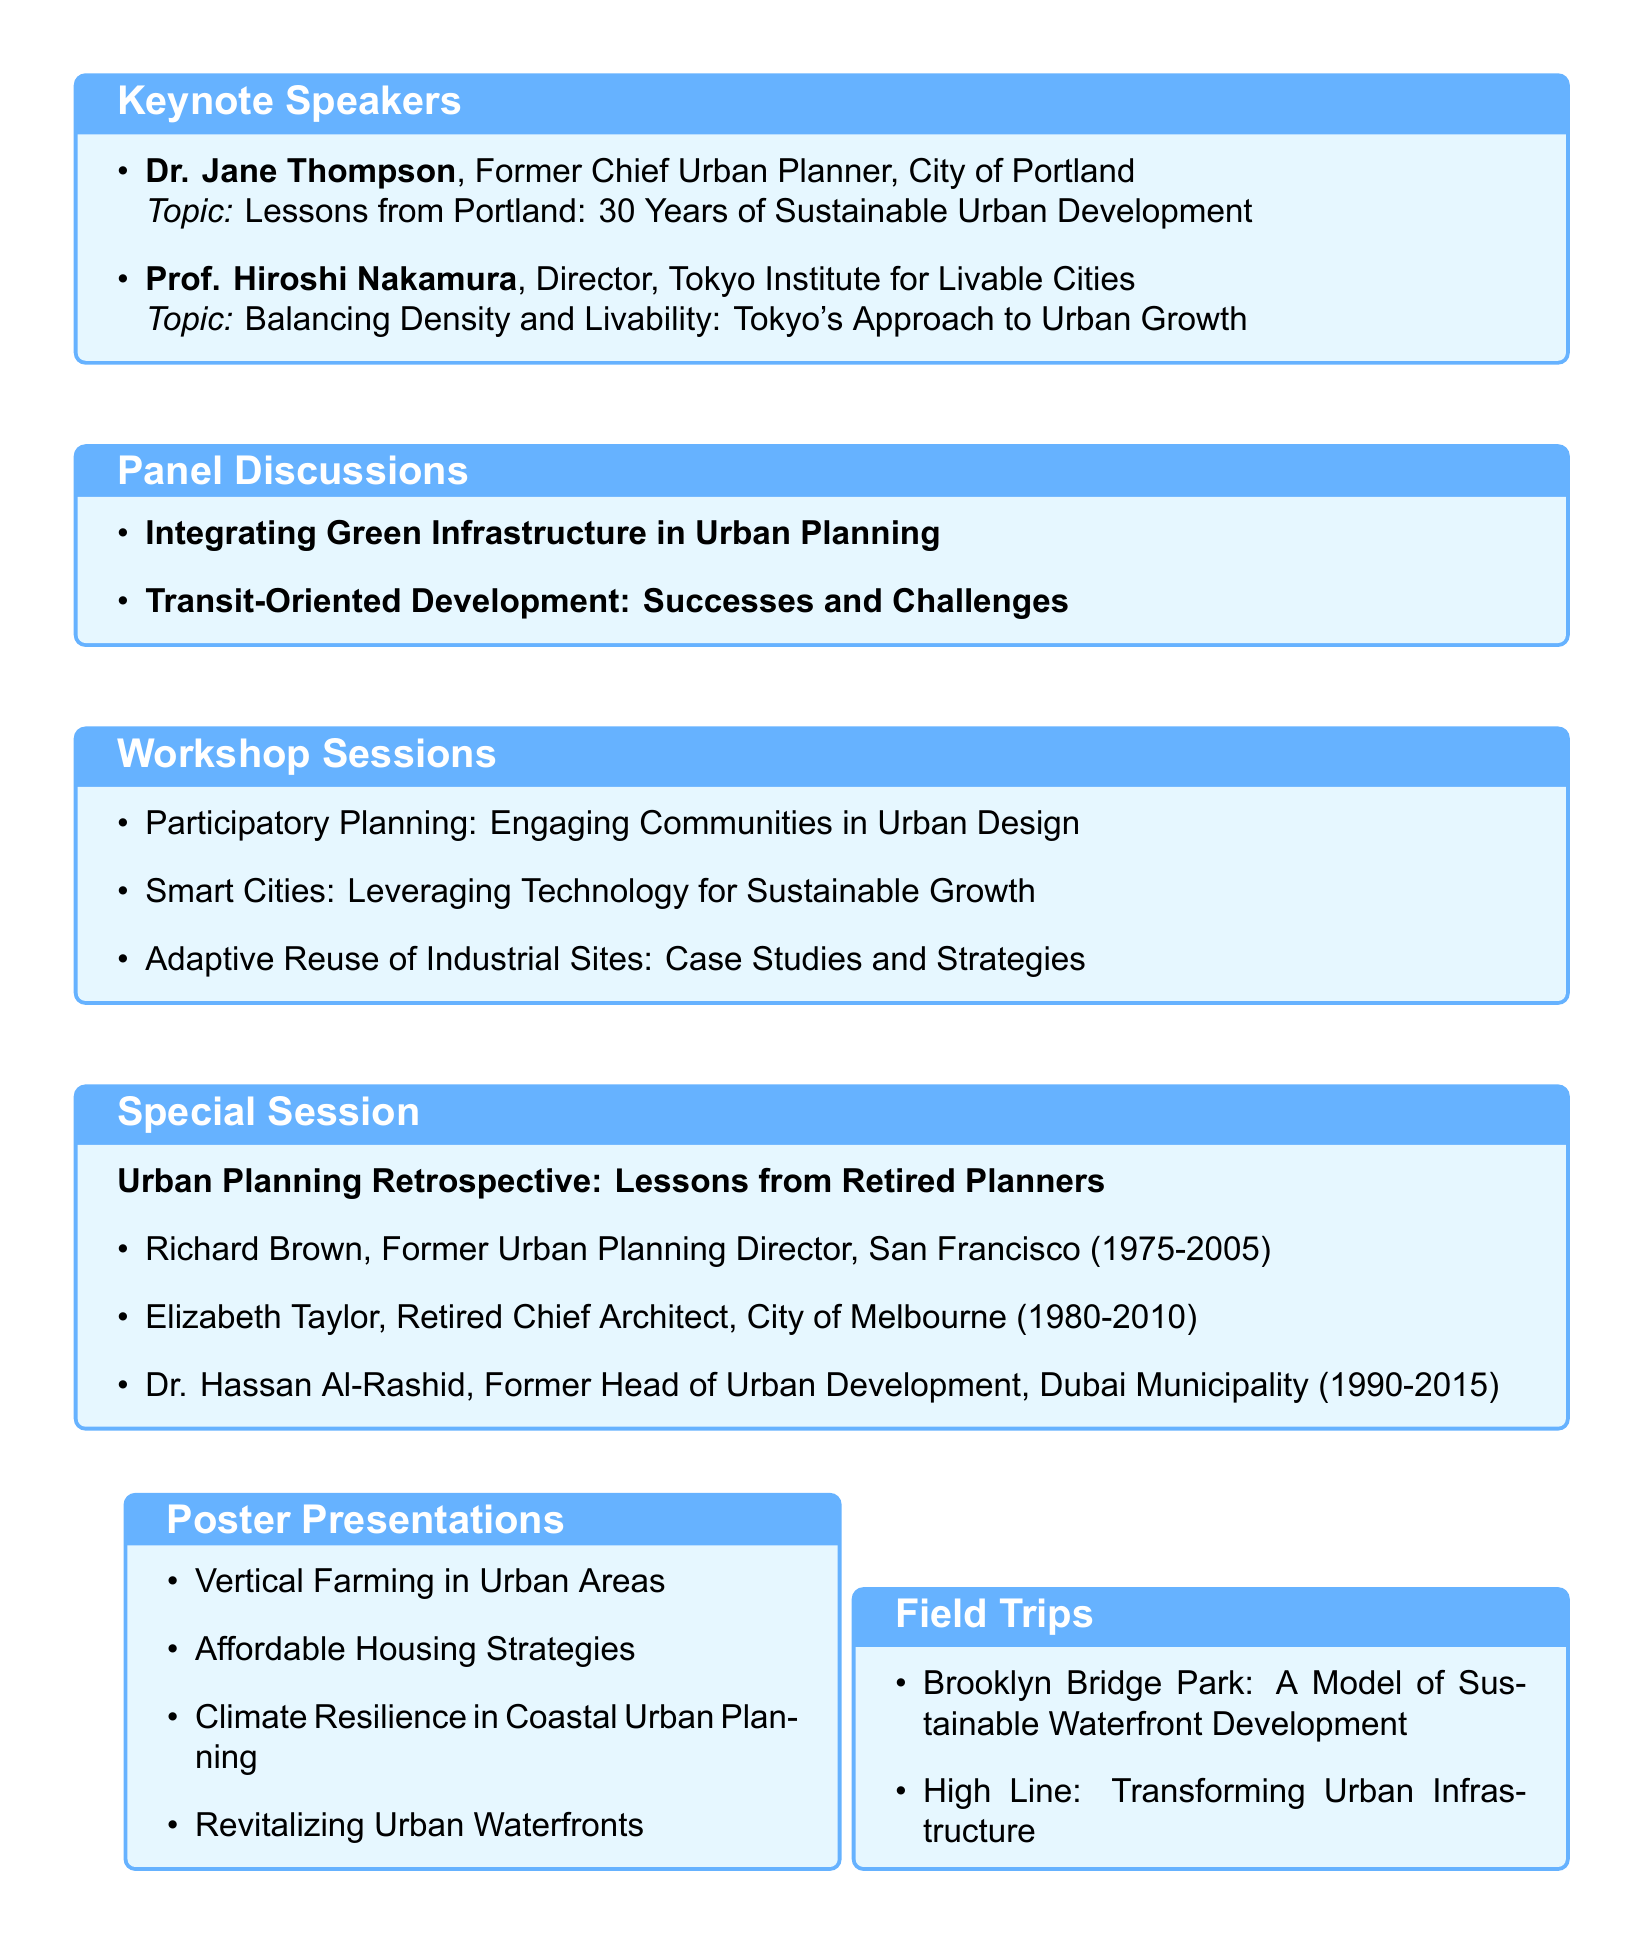What is the title of the symposium? The title of the symposium is "Sustainable Urban Growth Strategies: Shaping the Cities of Tomorrow."
Answer: Sustainable Urban Growth Strategies: Shaping the Cities of Tomorrow Who is the keynote speaker discussing Portland's lessons? The keynote speaker discussing Portland's lessons is Dr. Jane Thompson.
Answer: Dr. Jane Thompson How many days will the symposium take place? The document states the symposium will take place over three days, from October 15-17, 2023.
Answer: 3 days What is the venue for the symposium? The symposium will be held at the Urban Planning Institute in New York City.
Answer: Urban Planning Institute, New York City Who is the facilitator for the workshop on smart cities? The facilitator for the workshop on smart cities is Mark Williams.
Answer: Mark Williams What is one of the topics covered in the special session? One of the topics covered in the special session is "Urban Planning Retrospective: Lessons from Retired Planners."
Answer: Urban Planning Retrospective: Lessons from Retired Planners Name one speaker from the special session on retired planners. Richard Brown is one of the speakers in the special session.
Answer: Richard Brown What type of presentations are included in the symposium agenda? The document includes poster presentations as part of the symposium agenda.
Answer: Poster Presentations What is the title of the networking event held at the rooftop garden? The networking event held at the rooftop garden is the Welcome Reception.
Answer: Welcome Reception 